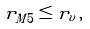Convert formula to latex. <formula><loc_0><loc_0><loc_500><loc_500>r _ { M 5 } \leq r _ { v } \, ,</formula> 